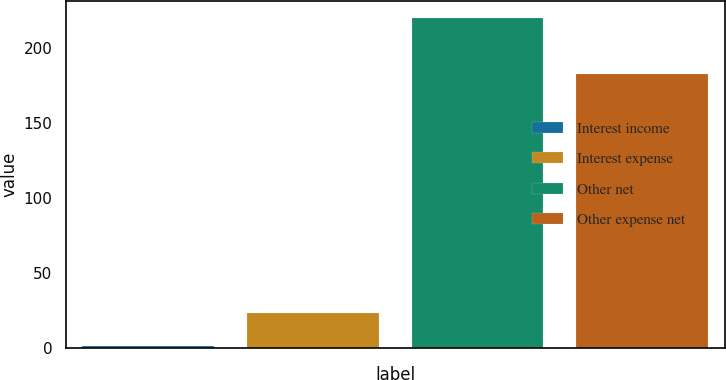Convert chart to OTSL. <chart><loc_0><loc_0><loc_500><loc_500><bar_chart><fcel>Interest income<fcel>Interest expense<fcel>Other net<fcel>Other expense net<nl><fcel>1.1<fcel>23.02<fcel>220.3<fcel>182.8<nl></chart> 